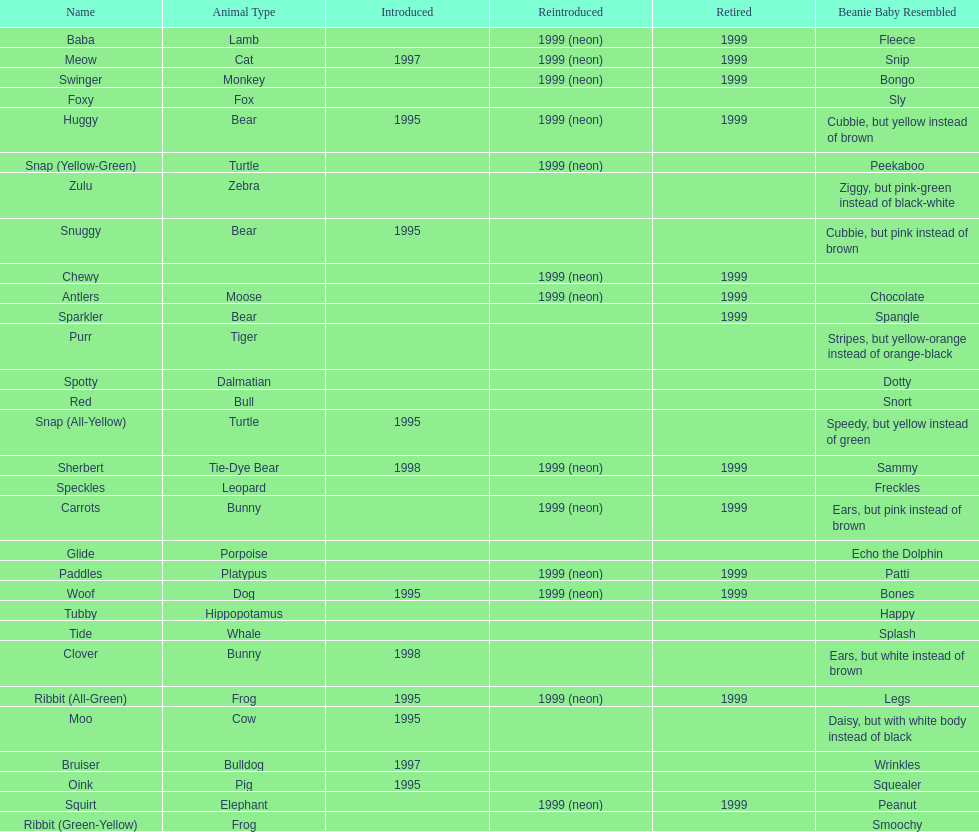How many monkey pillow pals were there? 1. 